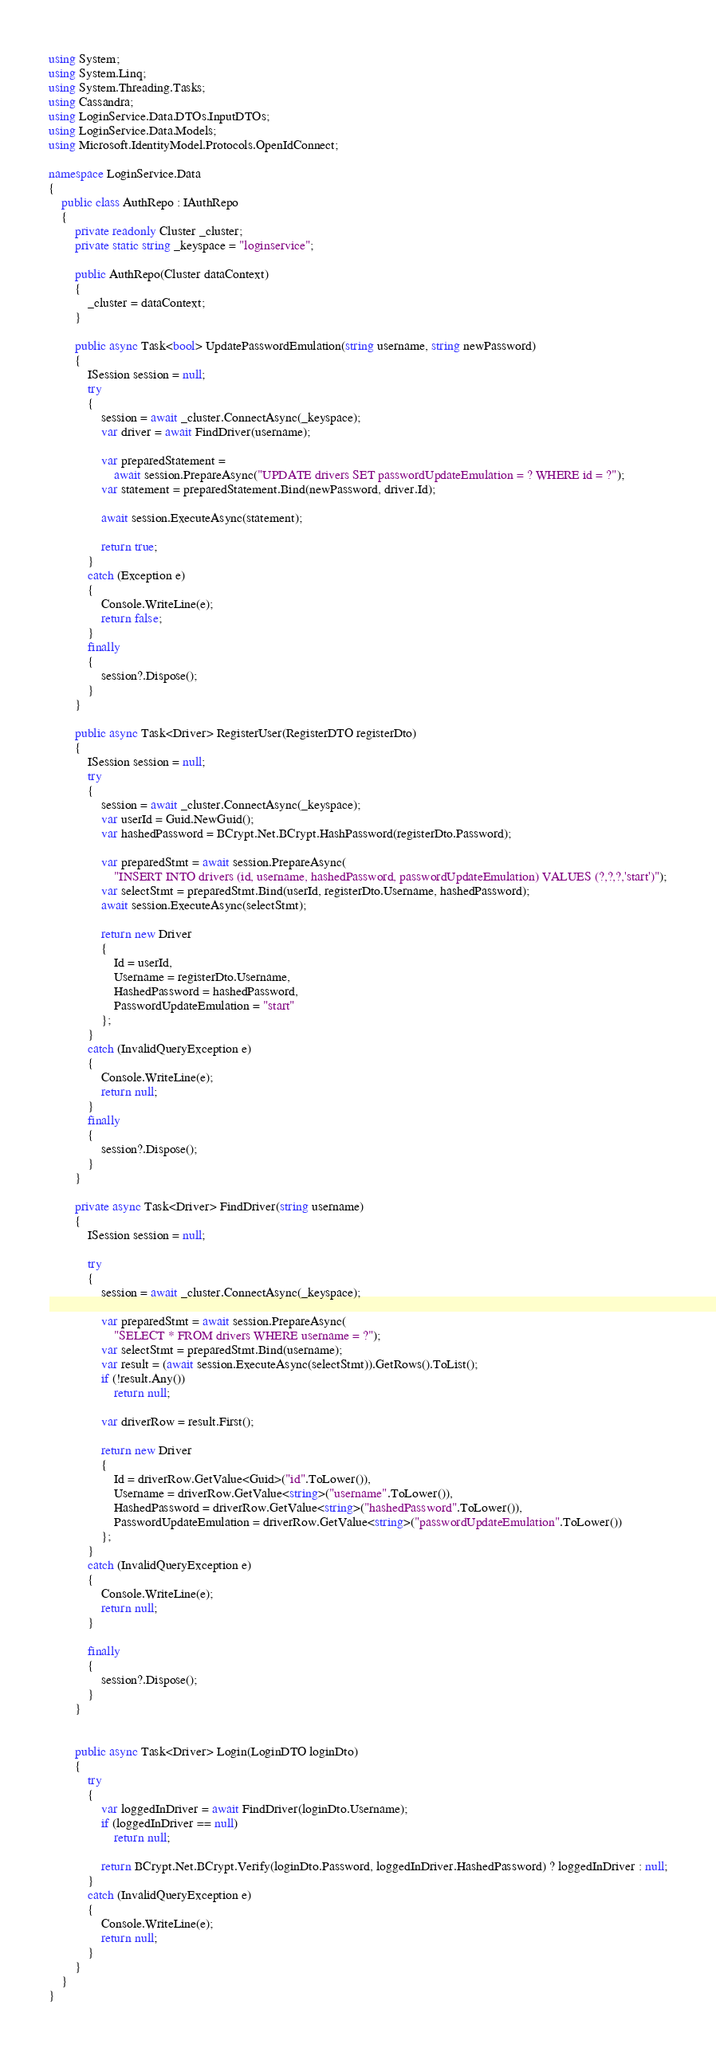Convert code to text. <code><loc_0><loc_0><loc_500><loc_500><_C#_>using System;
using System.Linq;
using System.Threading.Tasks;
using Cassandra;
using LoginService.Data.DTOs.InputDTOs;
using LoginService.Data.Models;
using Microsoft.IdentityModel.Protocols.OpenIdConnect;

namespace LoginService.Data
{
    public class AuthRepo : IAuthRepo
    {
        private readonly Cluster _cluster;
        private static string _keyspace = "loginservice";

        public AuthRepo(Cluster dataContext)
        {
            _cluster = dataContext;
        }

        public async Task<bool> UpdatePasswordEmulation(string username, string newPassword)
        {
            ISession session = null;
            try
            {
                session = await _cluster.ConnectAsync(_keyspace);
                var driver = await FindDriver(username);

                var preparedStatement =
                    await session.PrepareAsync("UPDATE drivers SET passwordUpdateEmulation = ? WHERE id = ?");
                var statement = preparedStatement.Bind(newPassword, driver.Id);
                
                await session.ExecuteAsync(statement);

                return true;
            }
            catch (Exception e)
            {
                Console.WriteLine(e);
                return false;
            }
            finally
            {
                session?.Dispose();
            }
        }

        public async Task<Driver> RegisterUser(RegisterDTO registerDto)
        {
            ISession session = null;
            try
            {
                session = await _cluster.ConnectAsync(_keyspace);
                var userId = Guid.NewGuid();
                var hashedPassword = BCrypt.Net.BCrypt.HashPassword(registerDto.Password);

                var preparedStmt = await session.PrepareAsync(
                    "INSERT INTO drivers (id, username, hashedPassword, passwordUpdateEmulation) VALUES (?,?,?,'start')");
                var selectStmt = preparedStmt.Bind(userId, registerDto.Username, hashedPassword);
                await session.ExecuteAsync(selectStmt);

                return new Driver
                {
                    Id = userId,
                    Username = registerDto.Username,
                    HashedPassword = hashedPassword,
                    PasswordUpdateEmulation = "start"
                };
            }
            catch (InvalidQueryException e)
            {
                Console.WriteLine(e);
                return null;
            }
            finally
            {
                session?.Dispose();
            }
        }

        private async Task<Driver> FindDriver(string username)
        {
            ISession session = null;

            try
            {
                session = await _cluster.ConnectAsync(_keyspace);

                var preparedStmt = await session.PrepareAsync(
                    "SELECT * FROM drivers WHERE username = ?");
                var selectStmt = preparedStmt.Bind(username);
                var result = (await session.ExecuteAsync(selectStmt)).GetRows().ToList();
                if (!result.Any())
                    return null;

                var driverRow = result.First();

                return new Driver
                {
                    Id = driverRow.GetValue<Guid>("id".ToLower()),
                    Username = driverRow.GetValue<string>("username".ToLower()),
                    HashedPassword = driverRow.GetValue<string>("hashedPassword".ToLower()),
                    PasswordUpdateEmulation = driverRow.GetValue<string>("passwordUpdateEmulation".ToLower())
                };
            }
            catch (InvalidQueryException e) 
            {
                Console.WriteLine(e);
                return null;
            }

            finally
            {
                session?.Dispose();
            }
        }


        public async Task<Driver> Login(LoginDTO loginDto)
        {
            try
            {
                var loggedInDriver = await FindDriver(loginDto.Username);
                if (loggedInDriver == null)
                    return null;

                return BCrypt.Net.BCrypt.Verify(loginDto.Password, loggedInDriver.HashedPassword) ? loggedInDriver : null;
            }
            catch (InvalidQueryException e)
            {
                Console.WriteLine(e);
                return null;
            }
        }
    }
}</code> 